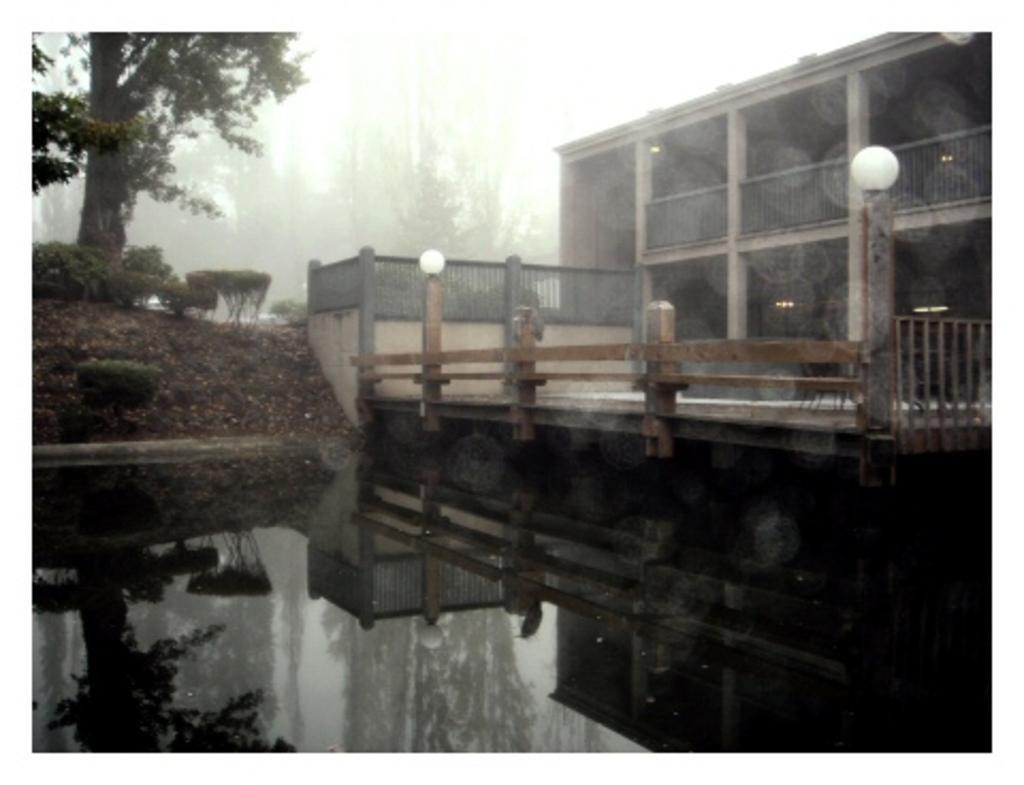Please provide a concise description of this image. In this image I can see the water, the railing, the ground, few trees, a building and few lights. In the background I can see the sky. 